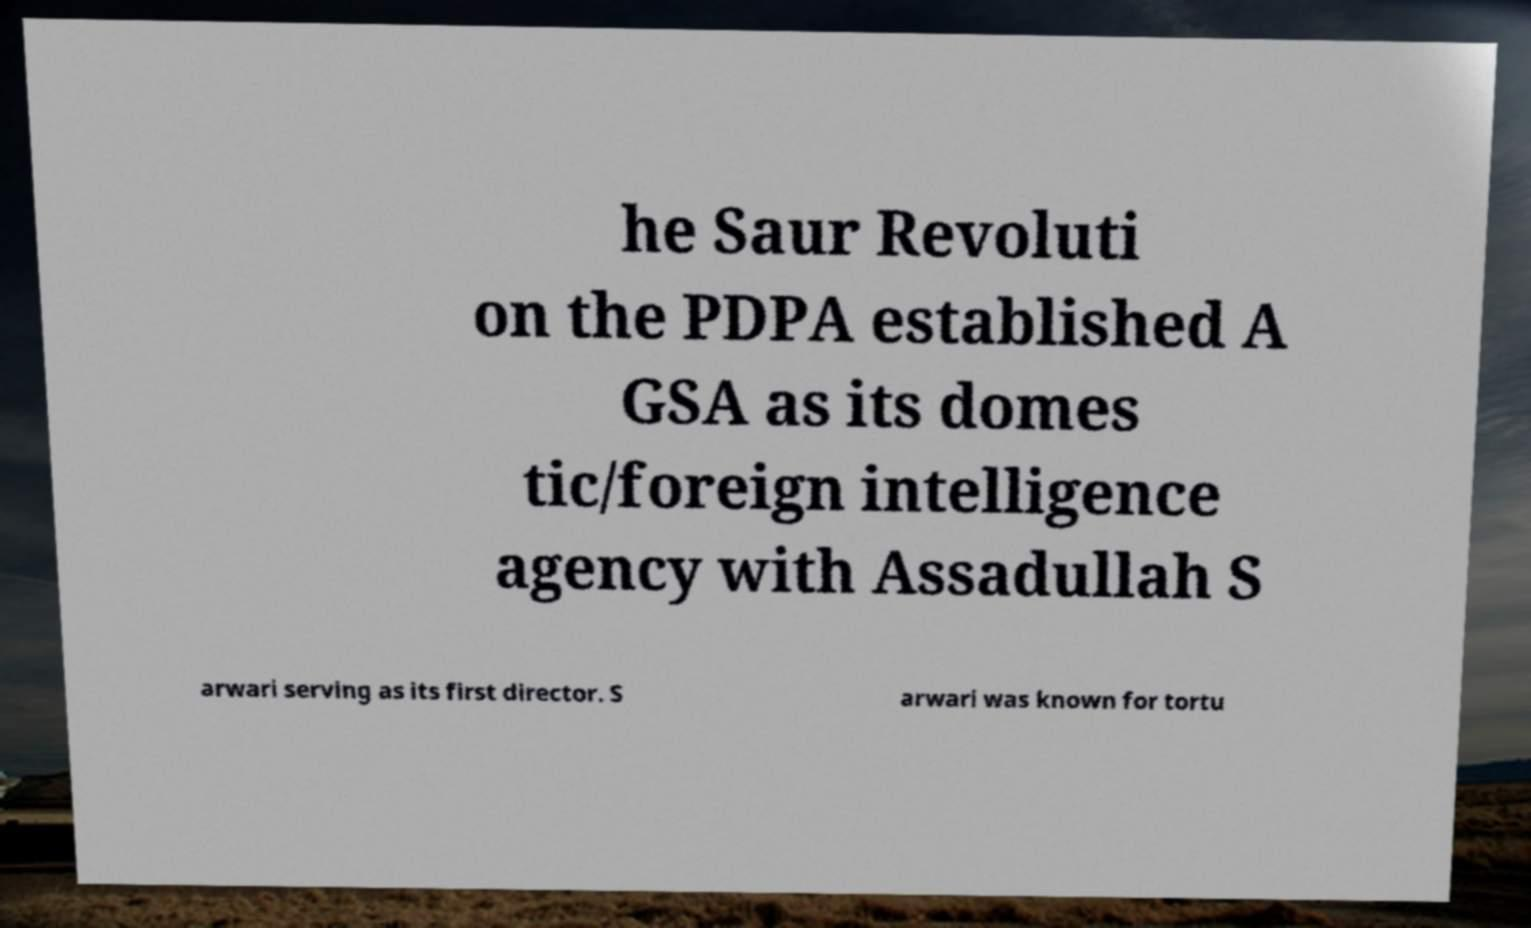Can you read and provide the text displayed in the image?This photo seems to have some interesting text. Can you extract and type it out for me? he Saur Revoluti on the PDPA established A GSA as its domes tic/foreign intelligence agency with Assadullah S arwari serving as its first director. S arwari was known for tortu 